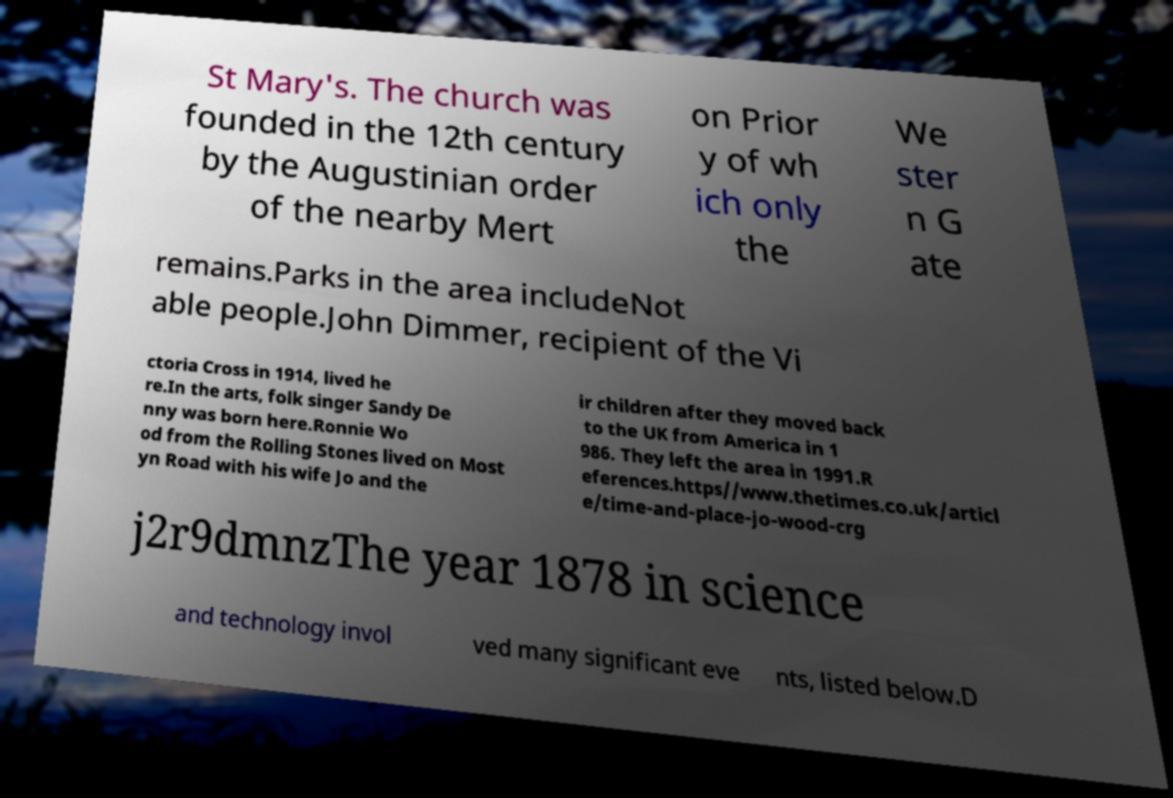Could you extract and type out the text from this image? St Mary's. The church was founded in the 12th century by the Augustinian order of the nearby Mert on Prior y of wh ich only the We ster n G ate remains.Parks in the area includeNot able people.John Dimmer, recipient of the Vi ctoria Cross in 1914, lived he re.In the arts, folk singer Sandy De nny was born here.Ronnie Wo od from the Rolling Stones lived on Most yn Road with his wife Jo and the ir children after they moved back to the UK from America in 1 986. They left the area in 1991.R eferences.https//www.thetimes.co.uk/articl e/time-and-place-jo-wood-crg j2r9dmnzThe year 1878 in science and technology invol ved many significant eve nts, listed below.D 